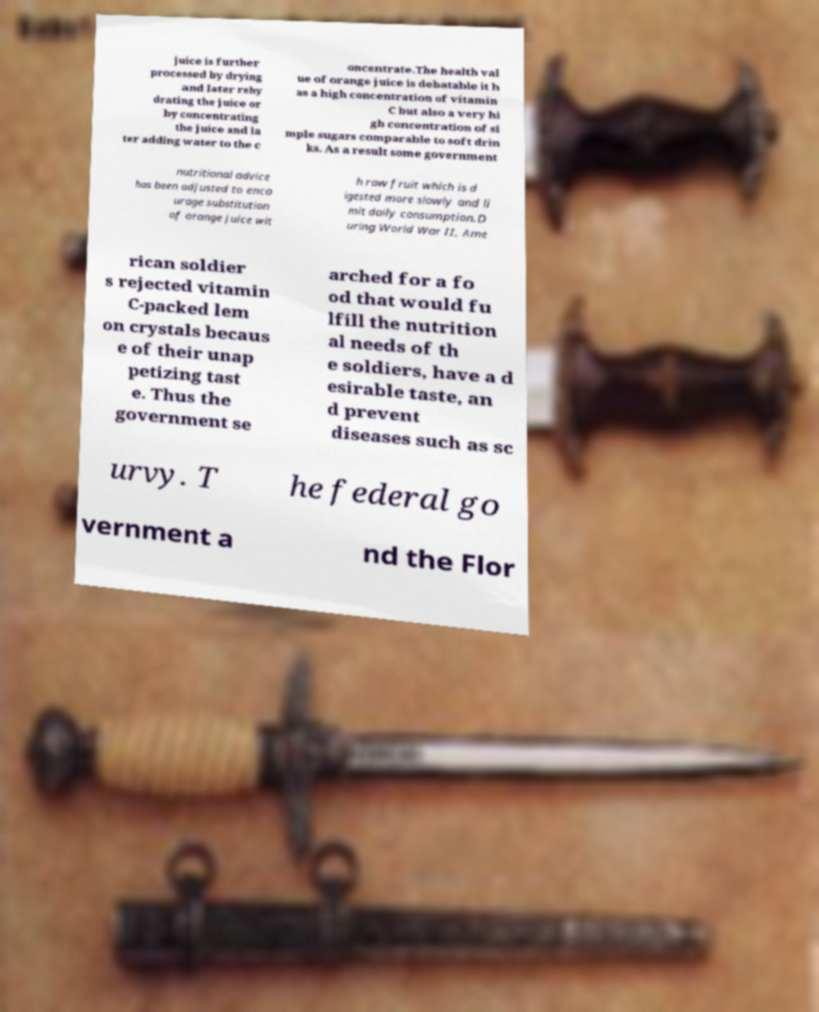There's text embedded in this image that I need extracted. Can you transcribe it verbatim? juice is further processed by drying and later rehy drating the juice or by concentrating the juice and la ter adding water to the c oncentrate.The health val ue of orange juice is debatable it h as a high concentration of vitamin C but also a very hi gh concentration of si mple sugars comparable to soft drin ks. As a result some government nutritional advice has been adjusted to enco urage substitution of orange juice wit h raw fruit which is d igested more slowly and li mit daily consumption.D uring World War II, Ame rican soldier s rejected vitamin C-packed lem on crystals becaus e of their unap petizing tast e. Thus the government se arched for a fo od that would fu lfill the nutrition al needs of th e soldiers, have a d esirable taste, an d prevent diseases such as sc urvy. T he federal go vernment a nd the Flor 